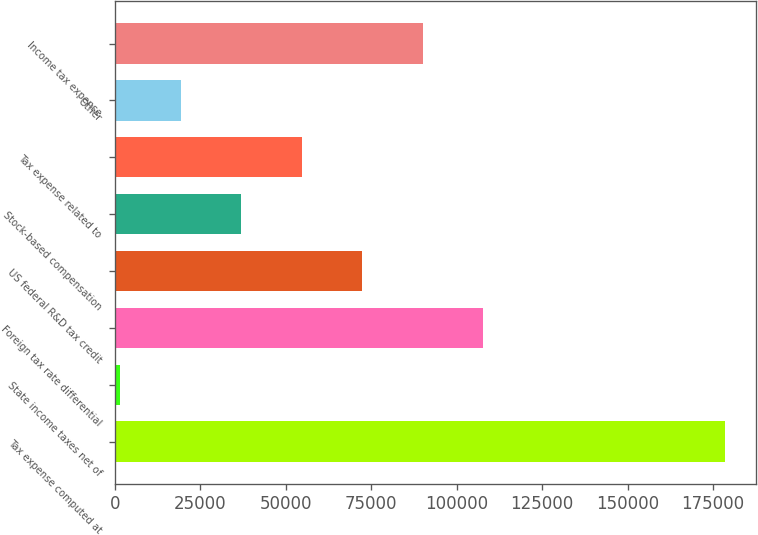Convert chart. <chart><loc_0><loc_0><loc_500><loc_500><bar_chart><fcel>Tax expense computed at<fcel>State income taxes net of<fcel>Foreign tax rate differential<fcel>US federal R&D tax credit<fcel>Stock-based compensation<fcel>Tax expense related to<fcel>Other<fcel>Income tax expense<nl><fcel>178589<fcel>1608<fcel>107797<fcel>72400.4<fcel>37004.2<fcel>54702.3<fcel>19306.1<fcel>90098.5<nl></chart> 